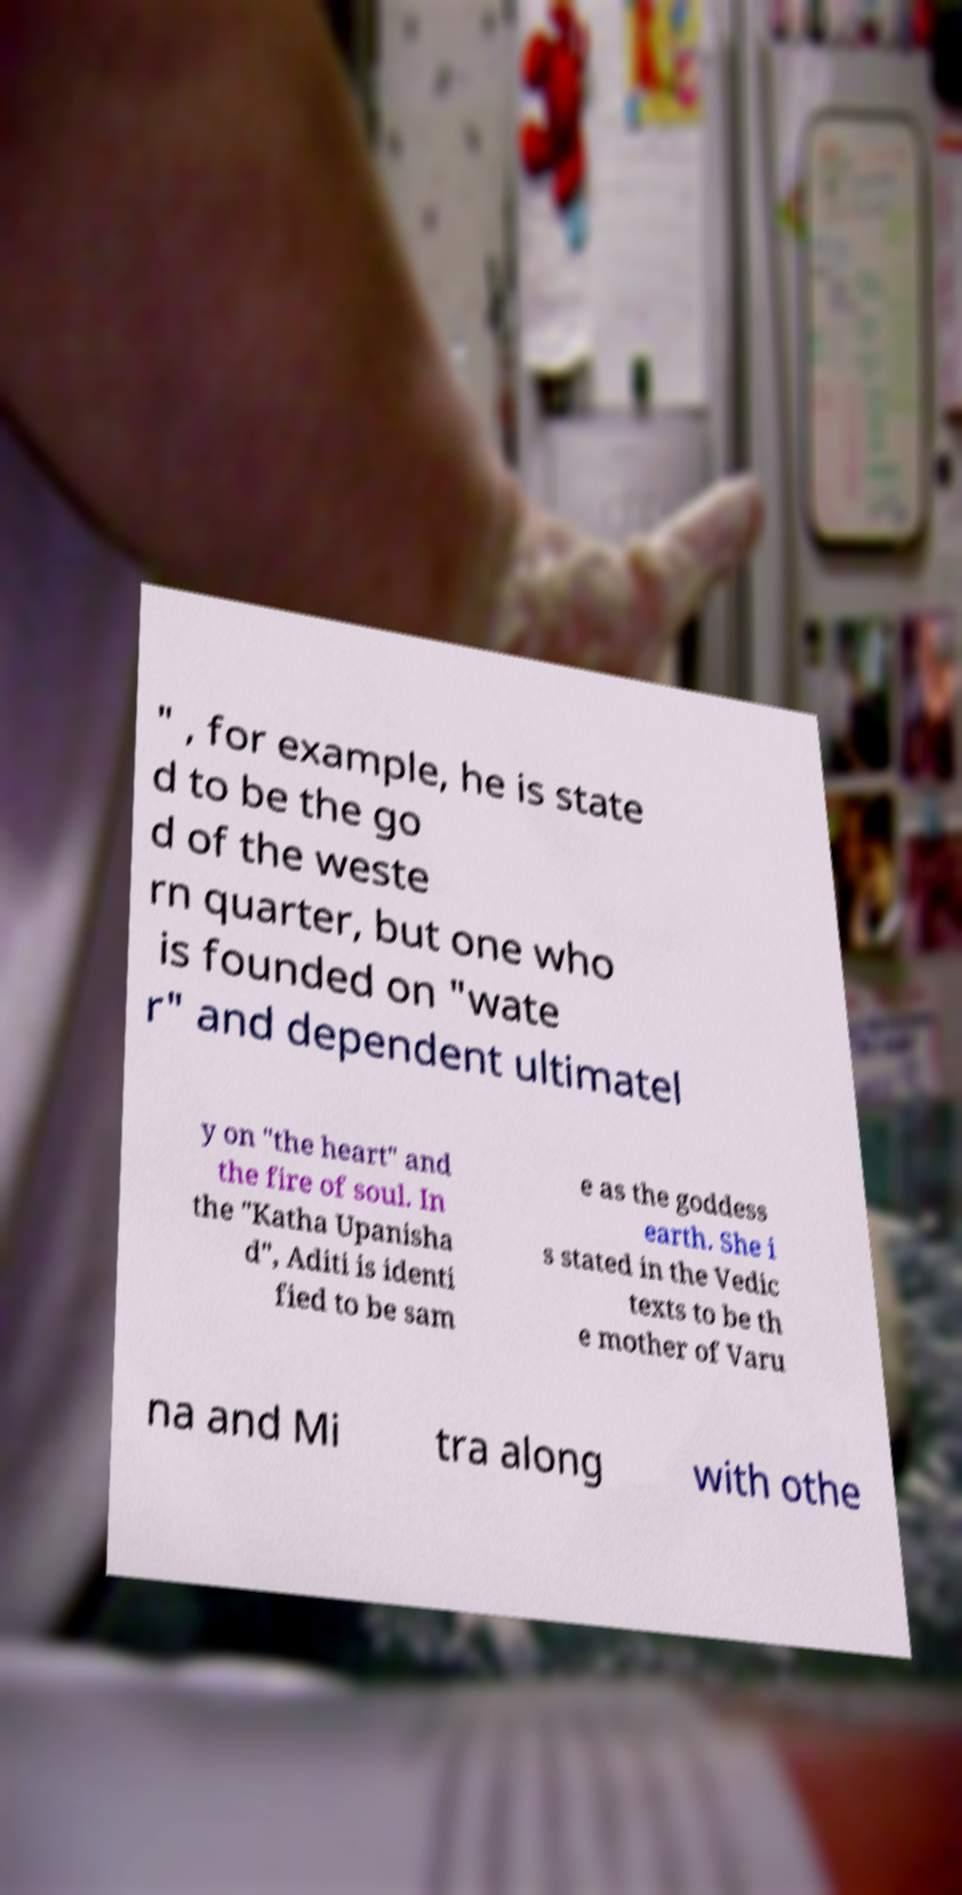I need the written content from this picture converted into text. Can you do that? " , for example, he is state d to be the go d of the weste rn quarter, but one who is founded on "wate r" and dependent ultimatel y on "the heart" and the fire of soul. In the "Katha Upanisha d", Aditi is identi fied to be sam e as the goddess earth. She i s stated in the Vedic texts to be th e mother of Varu na and Mi tra along with othe 